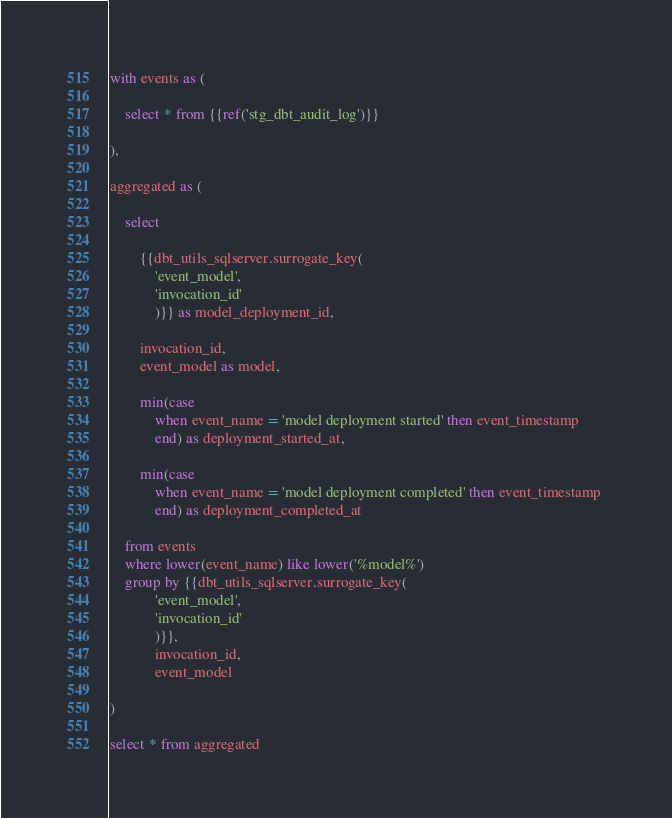<code> <loc_0><loc_0><loc_500><loc_500><_SQL_>with events as (

    select * from {{ref('stg_dbt_audit_log')}}

),

aggregated as (

    select 
    
        {{dbt_utils_sqlserver.surrogate_key(
            'event_model', 
            'invocation_id'
            )}} as model_deployment_id,
    
        invocation_id,
        event_model as model,
    
        min(case 
            when event_name = 'model deployment started' then event_timestamp 
            end) as deployment_started_at,
    
        min(case 
            when event_name = 'model deployment completed' then event_timestamp 
            end) as deployment_completed_at
    
    from events
    where lower(event_name) like lower('%model%')
    group by {{dbt_utils_sqlserver.surrogate_key(
            'event_model', 
            'invocation_id'
            )}},
            invocation_id,
            event_model

)

select * from aggregated</code> 